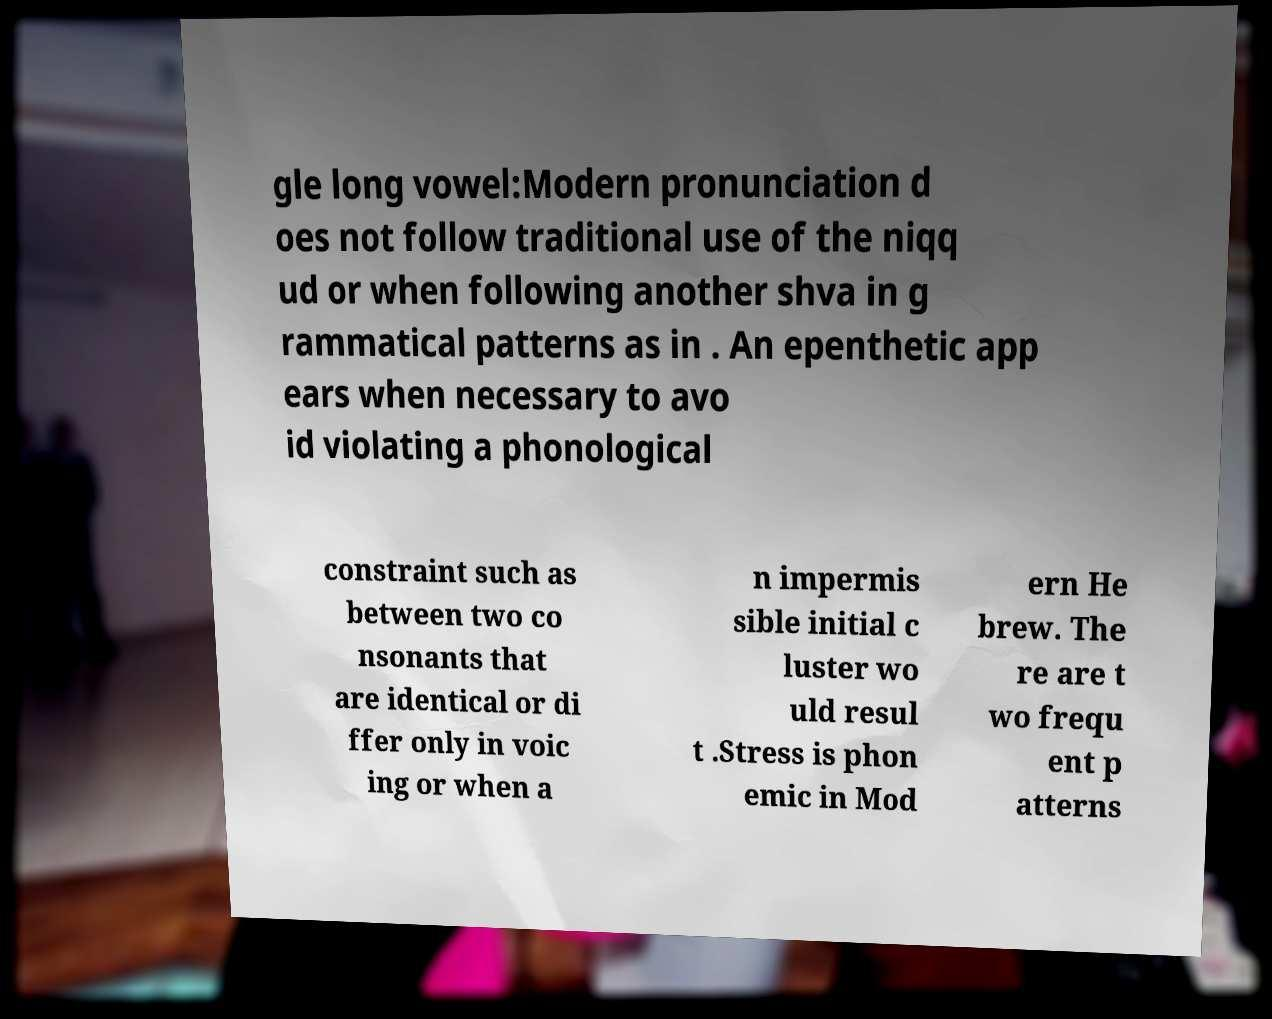Can you read and provide the text displayed in the image?This photo seems to have some interesting text. Can you extract and type it out for me? gle long vowel:Modern pronunciation d oes not follow traditional use of the niqq ud or when following another shva in g rammatical patterns as in . An epenthetic app ears when necessary to avo id violating a phonological constraint such as between two co nsonants that are identical or di ffer only in voic ing or when a n impermis sible initial c luster wo uld resul t .Stress is phon emic in Mod ern He brew. The re are t wo frequ ent p atterns 